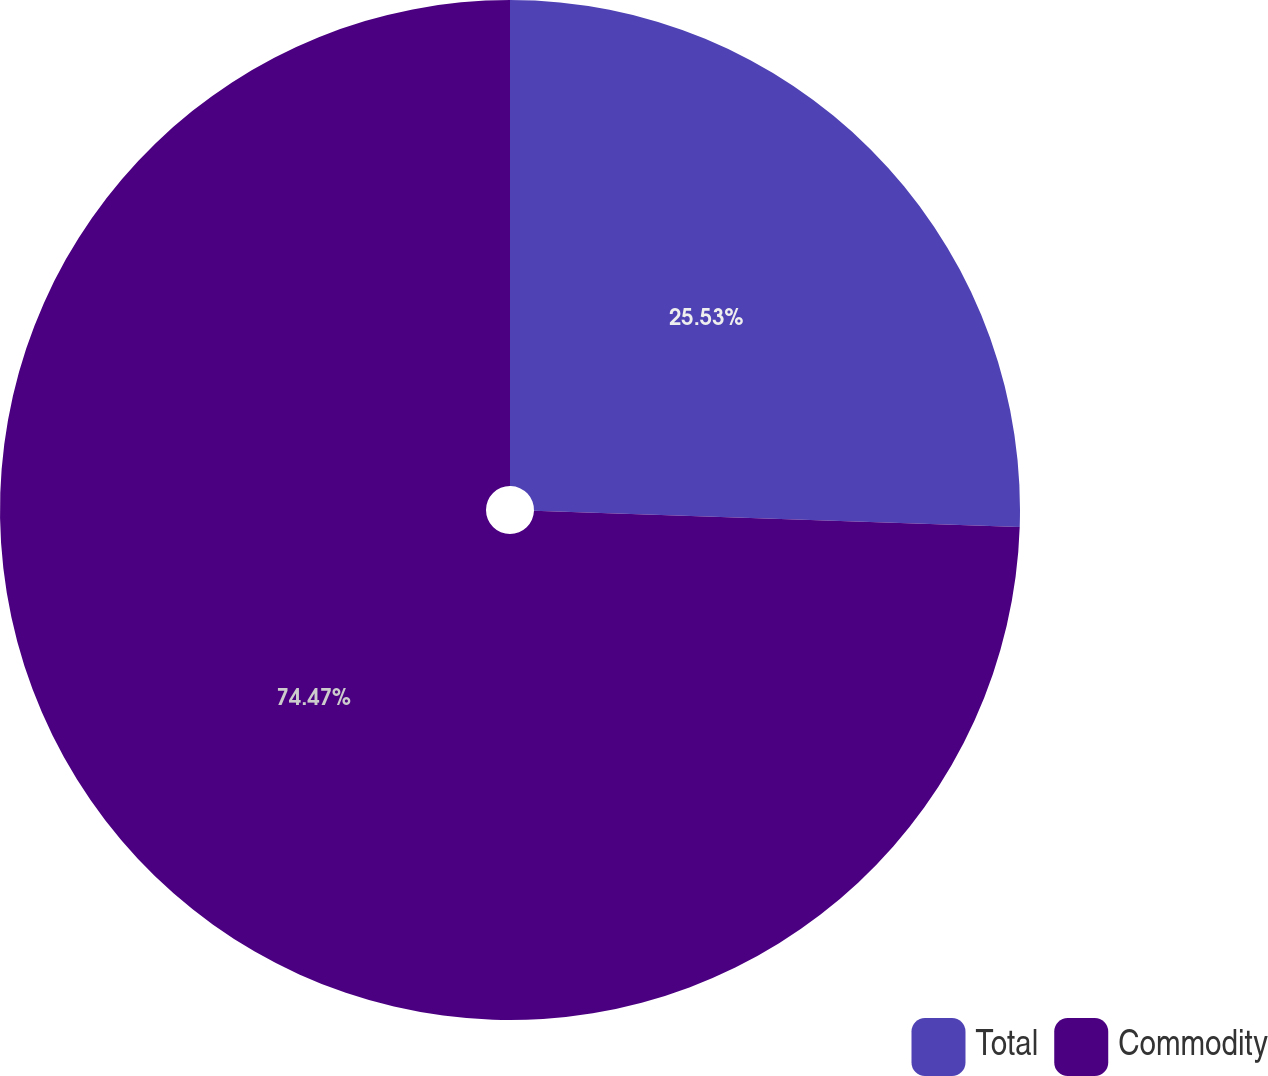Convert chart to OTSL. <chart><loc_0><loc_0><loc_500><loc_500><pie_chart><fcel>Total<fcel>Commodity<nl><fcel>25.53%<fcel>74.47%<nl></chart> 